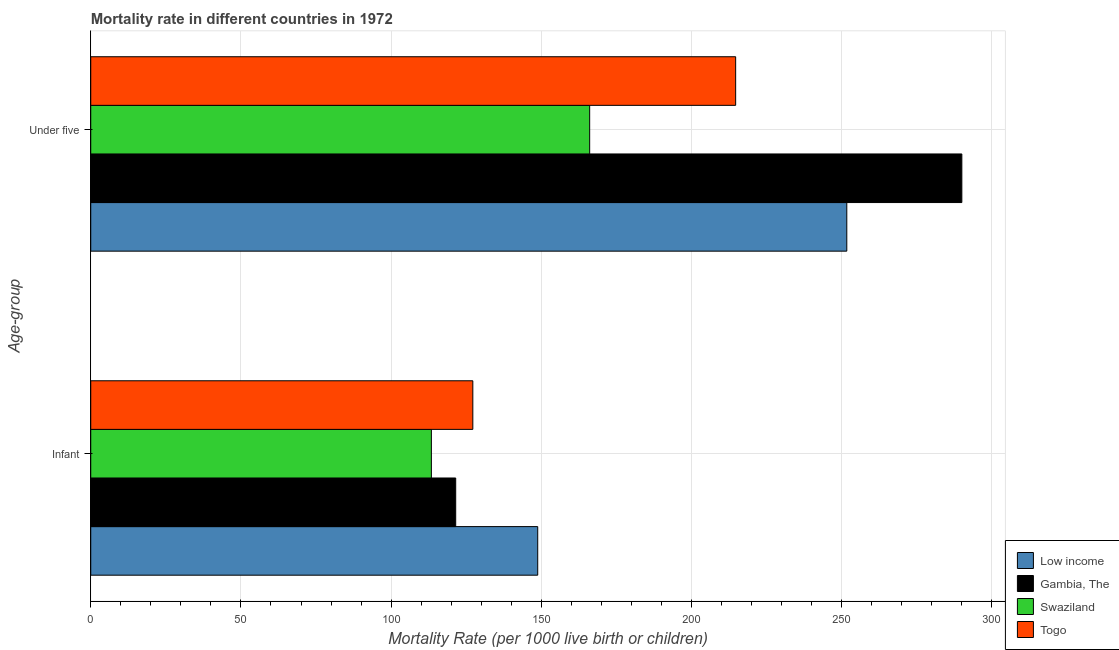Are the number of bars per tick equal to the number of legend labels?
Give a very brief answer. Yes. How many bars are there on the 2nd tick from the bottom?
Keep it short and to the point. 4. What is the label of the 2nd group of bars from the top?
Provide a short and direct response. Infant. What is the infant mortality rate in Togo?
Offer a terse response. 127.2. Across all countries, what is the maximum infant mortality rate?
Provide a short and direct response. 148.8. Across all countries, what is the minimum under-5 mortality rate?
Provide a succinct answer. 166.1. In which country was the under-5 mortality rate minimum?
Offer a terse response. Swaziland. What is the total under-5 mortality rate in the graph?
Your answer should be compact. 922.5. What is the difference between the infant mortality rate in Swaziland and that in Gambia, The?
Ensure brevity in your answer.  -8.1. What is the difference between the under-5 mortality rate in Swaziland and the infant mortality rate in Gambia, The?
Offer a very short reply. 44.6. What is the average infant mortality rate per country?
Offer a very short reply. 127.73. What is the difference between the under-5 mortality rate and infant mortality rate in Togo?
Your answer should be compact. 87.5. In how many countries, is the under-5 mortality rate greater than 270 ?
Your answer should be very brief. 1. What is the ratio of the under-5 mortality rate in Gambia, The to that in Togo?
Offer a terse response. 1.35. Is the under-5 mortality rate in Togo less than that in Low income?
Provide a succinct answer. Yes. What does the 3rd bar from the top in Infant represents?
Your response must be concise. Gambia, The. What does the 2nd bar from the bottom in Under five represents?
Keep it short and to the point. Gambia, The. How many countries are there in the graph?
Make the answer very short. 4. What is the difference between two consecutive major ticks on the X-axis?
Your response must be concise. 50. Where does the legend appear in the graph?
Your response must be concise. Bottom right. How are the legend labels stacked?
Ensure brevity in your answer.  Vertical. What is the title of the graph?
Offer a terse response. Mortality rate in different countries in 1972. Does "Bosnia and Herzegovina" appear as one of the legend labels in the graph?
Your answer should be very brief. No. What is the label or title of the X-axis?
Offer a terse response. Mortality Rate (per 1000 live birth or children). What is the label or title of the Y-axis?
Keep it short and to the point. Age-group. What is the Mortality Rate (per 1000 live birth or children) of Low income in Infant?
Provide a succinct answer. 148.8. What is the Mortality Rate (per 1000 live birth or children) of Gambia, The in Infant?
Give a very brief answer. 121.5. What is the Mortality Rate (per 1000 live birth or children) in Swaziland in Infant?
Ensure brevity in your answer.  113.4. What is the Mortality Rate (per 1000 live birth or children) in Togo in Infant?
Your answer should be compact. 127.2. What is the Mortality Rate (per 1000 live birth or children) of Low income in Under five?
Make the answer very short. 251.7. What is the Mortality Rate (per 1000 live birth or children) of Gambia, The in Under five?
Your answer should be very brief. 290. What is the Mortality Rate (per 1000 live birth or children) of Swaziland in Under five?
Provide a short and direct response. 166.1. What is the Mortality Rate (per 1000 live birth or children) in Togo in Under five?
Your answer should be very brief. 214.7. Across all Age-group, what is the maximum Mortality Rate (per 1000 live birth or children) in Low income?
Make the answer very short. 251.7. Across all Age-group, what is the maximum Mortality Rate (per 1000 live birth or children) of Gambia, The?
Your response must be concise. 290. Across all Age-group, what is the maximum Mortality Rate (per 1000 live birth or children) in Swaziland?
Offer a terse response. 166.1. Across all Age-group, what is the maximum Mortality Rate (per 1000 live birth or children) in Togo?
Your response must be concise. 214.7. Across all Age-group, what is the minimum Mortality Rate (per 1000 live birth or children) of Low income?
Offer a terse response. 148.8. Across all Age-group, what is the minimum Mortality Rate (per 1000 live birth or children) of Gambia, The?
Your answer should be very brief. 121.5. Across all Age-group, what is the minimum Mortality Rate (per 1000 live birth or children) in Swaziland?
Offer a terse response. 113.4. Across all Age-group, what is the minimum Mortality Rate (per 1000 live birth or children) of Togo?
Provide a short and direct response. 127.2. What is the total Mortality Rate (per 1000 live birth or children) of Low income in the graph?
Keep it short and to the point. 400.5. What is the total Mortality Rate (per 1000 live birth or children) of Gambia, The in the graph?
Keep it short and to the point. 411.5. What is the total Mortality Rate (per 1000 live birth or children) of Swaziland in the graph?
Offer a very short reply. 279.5. What is the total Mortality Rate (per 1000 live birth or children) in Togo in the graph?
Provide a succinct answer. 341.9. What is the difference between the Mortality Rate (per 1000 live birth or children) of Low income in Infant and that in Under five?
Offer a terse response. -102.9. What is the difference between the Mortality Rate (per 1000 live birth or children) of Gambia, The in Infant and that in Under five?
Ensure brevity in your answer.  -168.5. What is the difference between the Mortality Rate (per 1000 live birth or children) in Swaziland in Infant and that in Under five?
Give a very brief answer. -52.7. What is the difference between the Mortality Rate (per 1000 live birth or children) of Togo in Infant and that in Under five?
Make the answer very short. -87.5. What is the difference between the Mortality Rate (per 1000 live birth or children) of Low income in Infant and the Mortality Rate (per 1000 live birth or children) of Gambia, The in Under five?
Offer a very short reply. -141.2. What is the difference between the Mortality Rate (per 1000 live birth or children) of Low income in Infant and the Mortality Rate (per 1000 live birth or children) of Swaziland in Under five?
Provide a short and direct response. -17.3. What is the difference between the Mortality Rate (per 1000 live birth or children) of Low income in Infant and the Mortality Rate (per 1000 live birth or children) of Togo in Under five?
Your answer should be very brief. -65.9. What is the difference between the Mortality Rate (per 1000 live birth or children) of Gambia, The in Infant and the Mortality Rate (per 1000 live birth or children) of Swaziland in Under five?
Your response must be concise. -44.6. What is the difference between the Mortality Rate (per 1000 live birth or children) of Gambia, The in Infant and the Mortality Rate (per 1000 live birth or children) of Togo in Under five?
Offer a very short reply. -93.2. What is the difference between the Mortality Rate (per 1000 live birth or children) of Swaziland in Infant and the Mortality Rate (per 1000 live birth or children) of Togo in Under five?
Ensure brevity in your answer.  -101.3. What is the average Mortality Rate (per 1000 live birth or children) of Low income per Age-group?
Give a very brief answer. 200.25. What is the average Mortality Rate (per 1000 live birth or children) in Gambia, The per Age-group?
Make the answer very short. 205.75. What is the average Mortality Rate (per 1000 live birth or children) in Swaziland per Age-group?
Offer a very short reply. 139.75. What is the average Mortality Rate (per 1000 live birth or children) in Togo per Age-group?
Your answer should be compact. 170.95. What is the difference between the Mortality Rate (per 1000 live birth or children) in Low income and Mortality Rate (per 1000 live birth or children) in Gambia, The in Infant?
Make the answer very short. 27.3. What is the difference between the Mortality Rate (per 1000 live birth or children) in Low income and Mortality Rate (per 1000 live birth or children) in Swaziland in Infant?
Provide a short and direct response. 35.4. What is the difference between the Mortality Rate (per 1000 live birth or children) of Low income and Mortality Rate (per 1000 live birth or children) of Togo in Infant?
Provide a succinct answer. 21.6. What is the difference between the Mortality Rate (per 1000 live birth or children) in Gambia, The and Mortality Rate (per 1000 live birth or children) in Swaziland in Infant?
Keep it short and to the point. 8.1. What is the difference between the Mortality Rate (per 1000 live birth or children) of Gambia, The and Mortality Rate (per 1000 live birth or children) of Togo in Infant?
Your answer should be compact. -5.7. What is the difference between the Mortality Rate (per 1000 live birth or children) in Low income and Mortality Rate (per 1000 live birth or children) in Gambia, The in Under five?
Your answer should be very brief. -38.3. What is the difference between the Mortality Rate (per 1000 live birth or children) in Low income and Mortality Rate (per 1000 live birth or children) in Swaziland in Under five?
Offer a very short reply. 85.6. What is the difference between the Mortality Rate (per 1000 live birth or children) in Low income and Mortality Rate (per 1000 live birth or children) in Togo in Under five?
Give a very brief answer. 37. What is the difference between the Mortality Rate (per 1000 live birth or children) in Gambia, The and Mortality Rate (per 1000 live birth or children) in Swaziland in Under five?
Give a very brief answer. 123.9. What is the difference between the Mortality Rate (per 1000 live birth or children) of Gambia, The and Mortality Rate (per 1000 live birth or children) of Togo in Under five?
Your response must be concise. 75.3. What is the difference between the Mortality Rate (per 1000 live birth or children) of Swaziland and Mortality Rate (per 1000 live birth or children) of Togo in Under five?
Offer a very short reply. -48.6. What is the ratio of the Mortality Rate (per 1000 live birth or children) in Low income in Infant to that in Under five?
Your answer should be compact. 0.59. What is the ratio of the Mortality Rate (per 1000 live birth or children) of Gambia, The in Infant to that in Under five?
Keep it short and to the point. 0.42. What is the ratio of the Mortality Rate (per 1000 live birth or children) in Swaziland in Infant to that in Under five?
Offer a terse response. 0.68. What is the ratio of the Mortality Rate (per 1000 live birth or children) of Togo in Infant to that in Under five?
Offer a terse response. 0.59. What is the difference between the highest and the second highest Mortality Rate (per 1000 live birth or children) of Low income?
Ensure brevity in your answer.  102.9. What is the difference between the highest and the second highest Mortality Rate (per 1000 live birth or children) in Gambia, The?
Your response must be concise. 168.5. What is the difference between the highest and the second highest Mortality Rate (per 1000 live birth or children) of Swaziland?
Make the answer very short. 52.7. What is the difference between the highest and the second highest Mortality Rate (per 1000 live birth or children) in Togo?
Provide a succinct answer. 87.5. What is the difference between the highest and the lowest Mortality Rate (per 1000 live birth or children) in Low income?
Make the answer very short. 102.9. What is the difference between the highest and the lowest Mortality Rate (per 1000 live birth or children) in Gambia, The?
Your answer should be compact. 168.5. What is the difference between the highest and the lowest Mortality Rate (per 1000 live birth or children) in Swaziland?
Your answer should be compact. 52.7. What is the difference between the highest and the lowest Mortality Rate (per 1000 live birth or children) of Togo?
Your response must be concise. 87.5. 